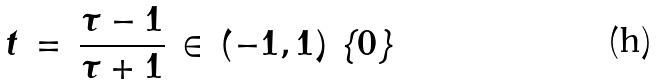Convert formula to latex. <formula><loc_0><loc_0><loc_500><loc_500>t \, = \, \frac { \tau - 1 } { \tau + 1 } \, \in \, ( - 1 , 1 ) \ \{ 0 \}</formula> 